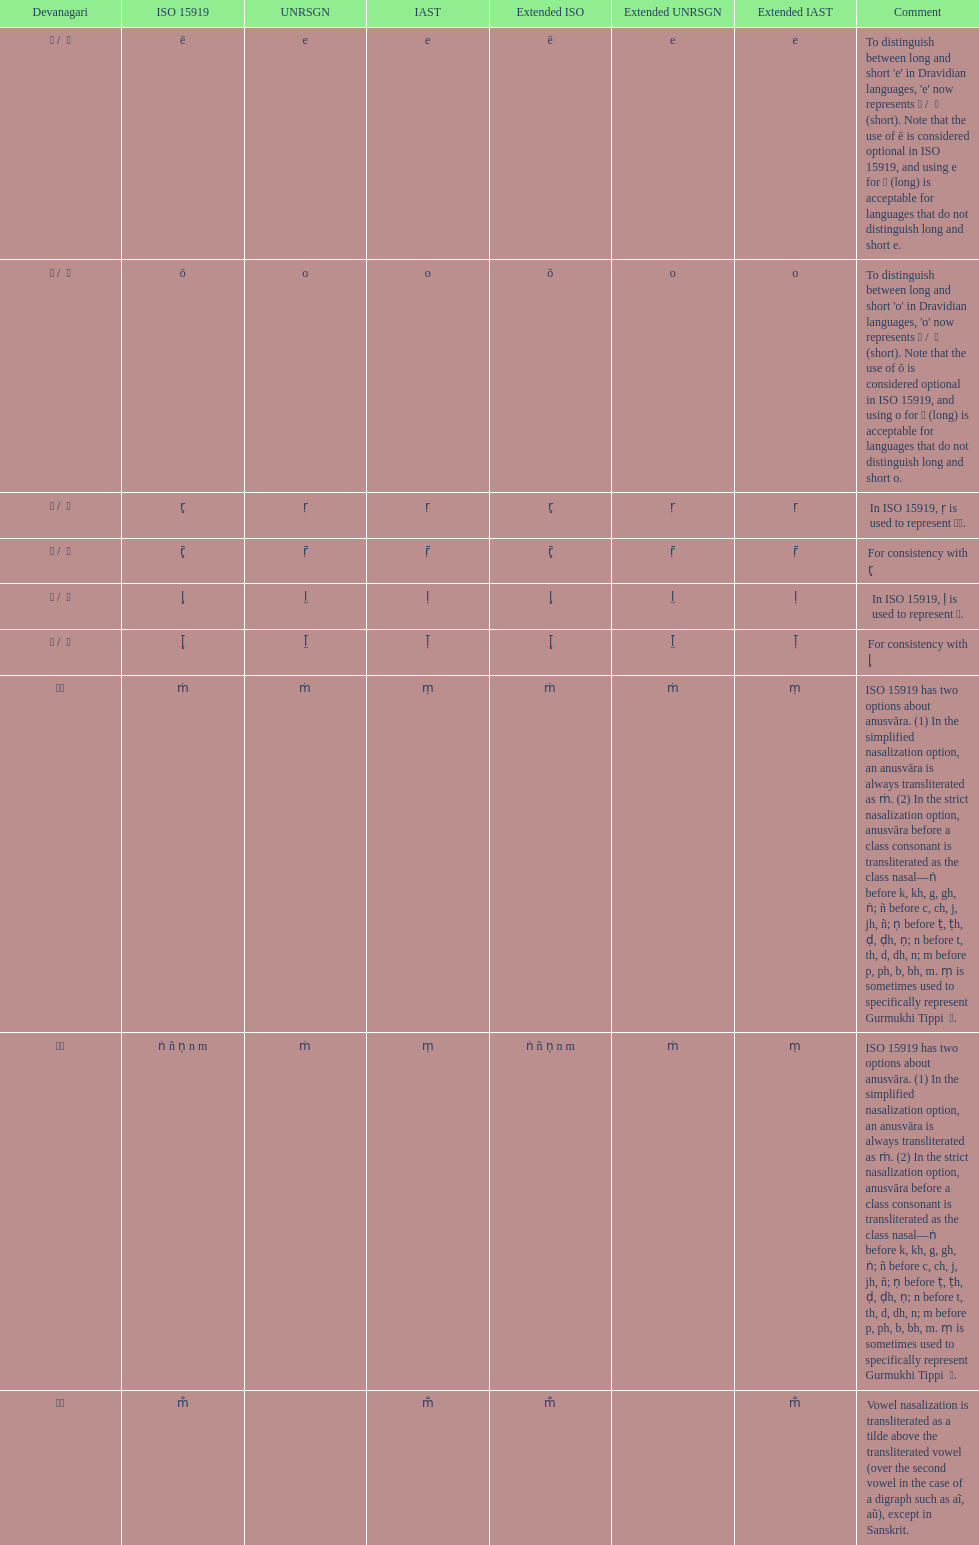This table shows the difference between how many transliterations? 3. 